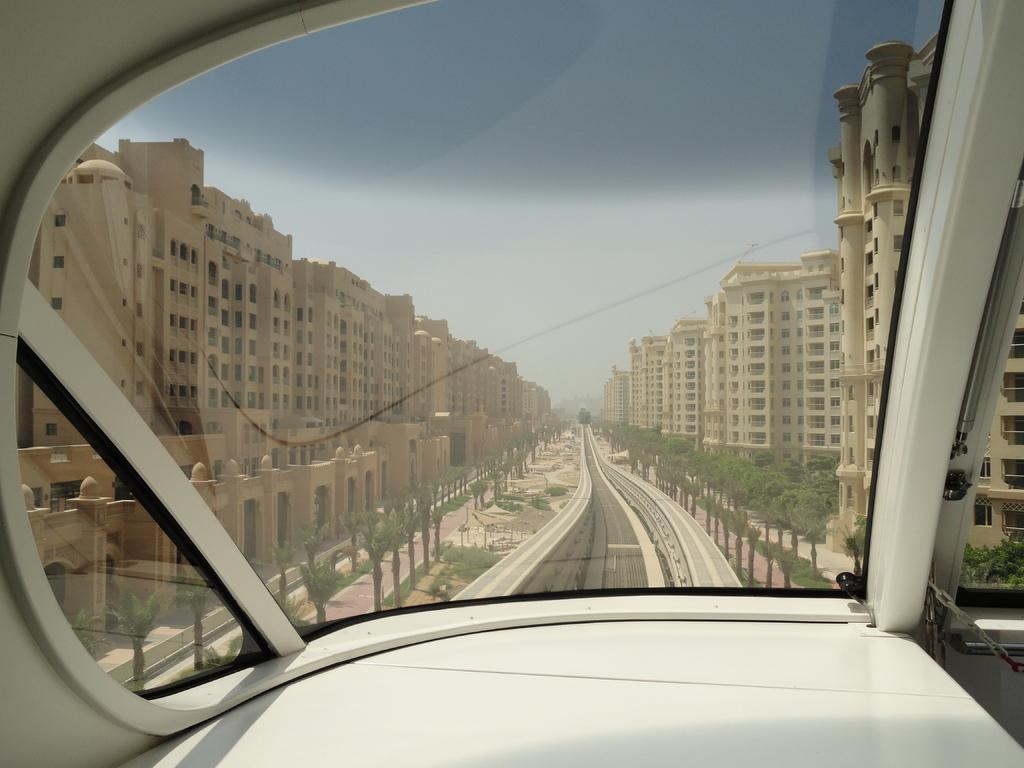What is the perspective of the image? The image was captured from inside a vehicle. What can be seen in the background of the image? There are buildings, plants, trees, poles, and the sky visible in the background of the image. What action is being performed by the baby in the image? There is no baby present in the image. What event is being celebrated in the image? There is no event being celebrated in the image. 